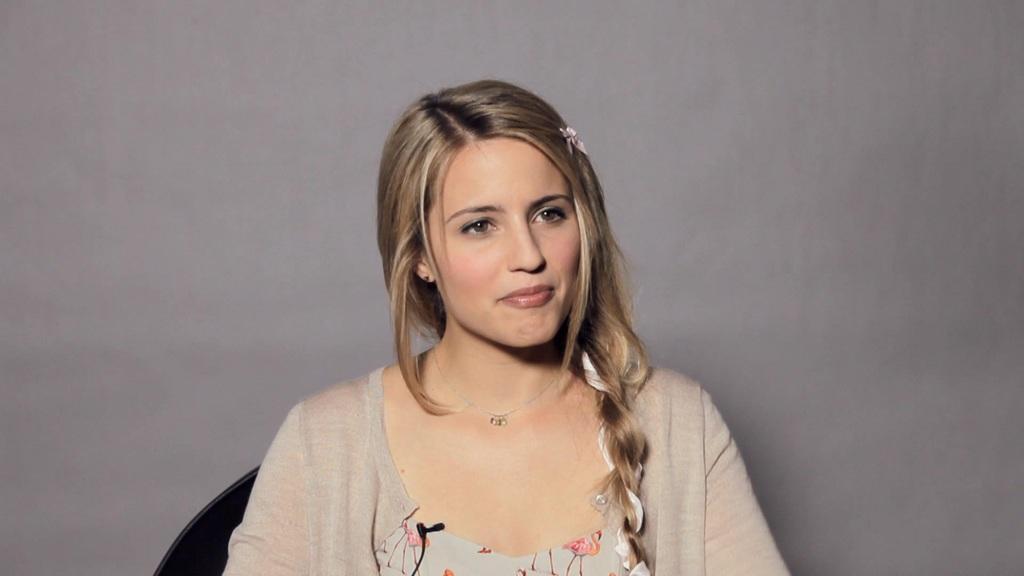Could you give a brief overview of what you see in this image? In this image we can see a woman with a smiling face and we can also see a light color background. 